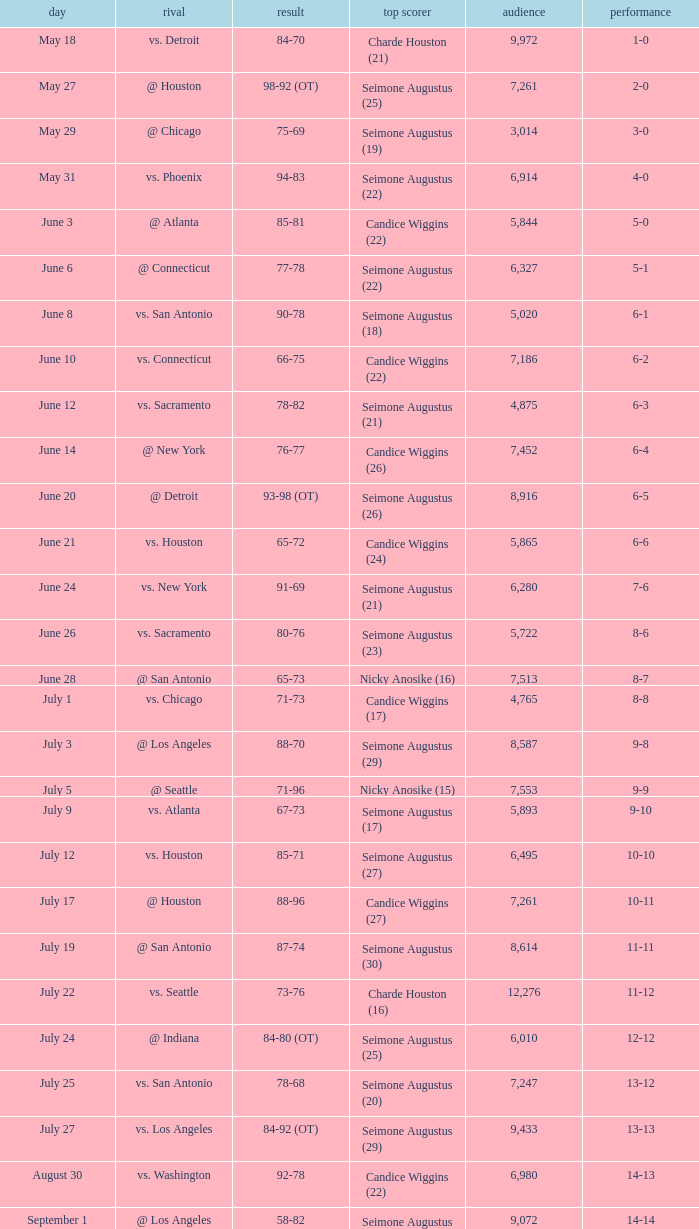Which Attendance has a Date of september 7? 7999.0. 